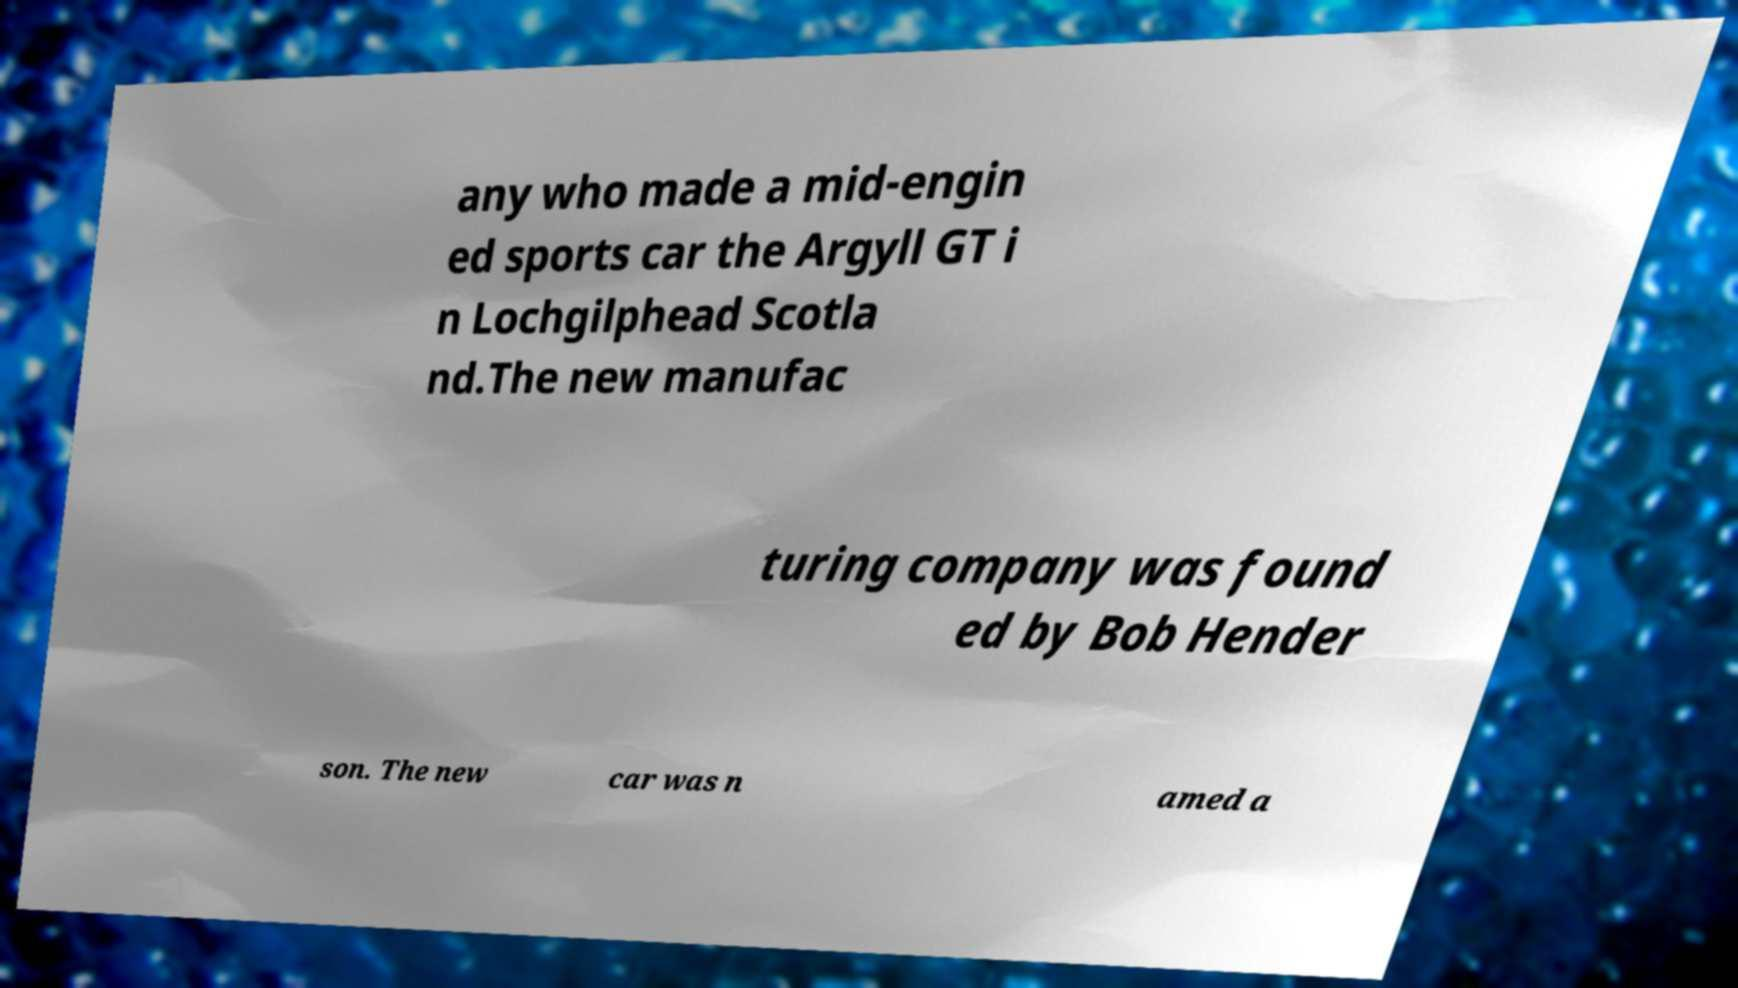I need the written content from this picture converted into text. Can you do that? any who made a mid-engin ed sports car the Argyll GT i n Lochgilphead Scotla nd.The new manufac turing company was found ed by Bob Hender son. The new car was n amed a 